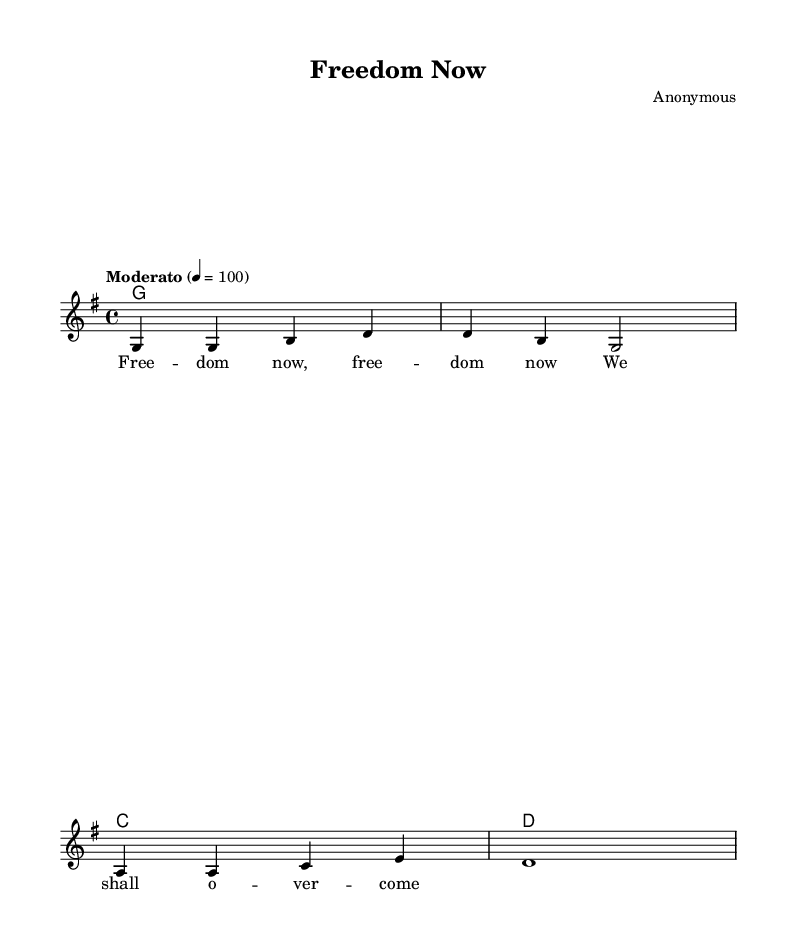What is the key signature of this music? The key signature is G major, which features one sharp: F#. This can be identified at the beginning of the staff in the key signature section.
Answer: G major What is the time signature of this music? The time signature is 4/4, meaning there are four beats per measure and a quarter note receives one beat. This is noted at the beginning of the score, directly following the key signature.
Answer: 4/4 What is the tempo marking of this piece? The tempo marking is "Moderato," which indicates a moderate pace. This is found at the beginning of the score, indicating how fast or slow the music should be played.
Answer: Moderato What type of chord is played in the first measure? The chord in the first measure is a G major chord, as indicated by the chord names above the staff. The presence of the root note G and its harmonizing notes can also confirm this.
Answer: G major How many measures does the melody contain? The melody contains four measures, which can be counted by identifying the bar lines separating each measure in the notation.
Answer: 4 Which line or space starts the melody? The melody starts on the note G, which is located on the second line of the treble clef staff. This can be noticed by observing the first note of the melody in the score.
Answer: G What phrase is repeated in the lyrics? The phrase "freedom now" is repeated in the lyrics. This can be recognized as it appears multiple times within the text under the notes.
Answer: freedom now 